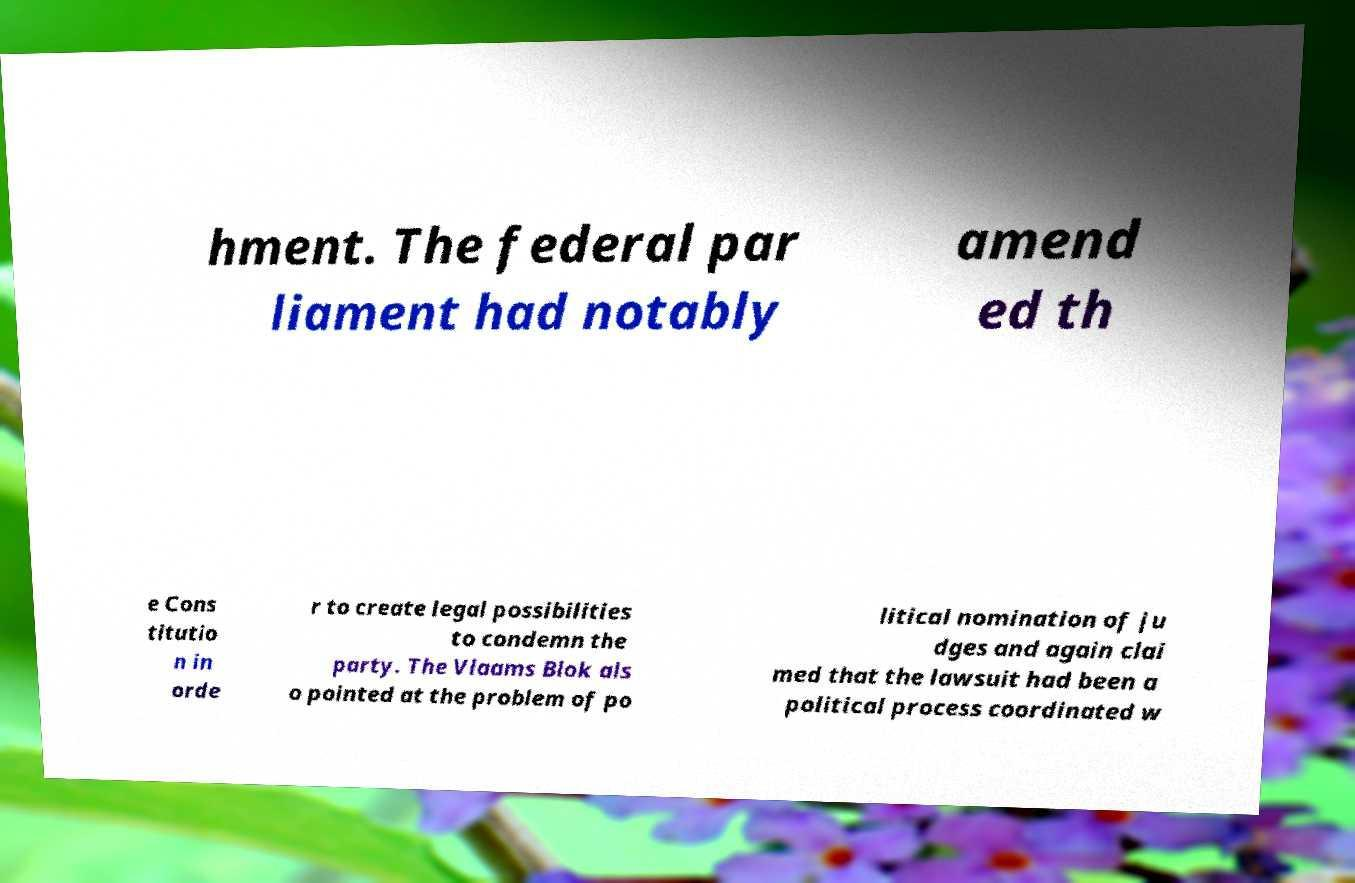Could you assist in decoding the text presented in this image and type it out clearly? hment. The federal par liament had notably amend ed th e Cons titutio n in orde r to create legal possibilities to condemn the party. The Vlaams Blok als o pointed at the problem of po litical nomination of ju dges and again clai med that the lawsuit had been a political process coordinated w 